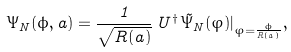<formula> <loc_0><loc_0><loc_500><loc_500>\Psi _ { N } ( \phi , a ) = \frac { 1 } { \sqrt { R ( a ) } } \, U ^ { \dag } \, \tilde { \Psi } _ { N } ( \varphi ) | _ { \varphi = \frac { \phi } { R ( a ) } } ,</formula> 